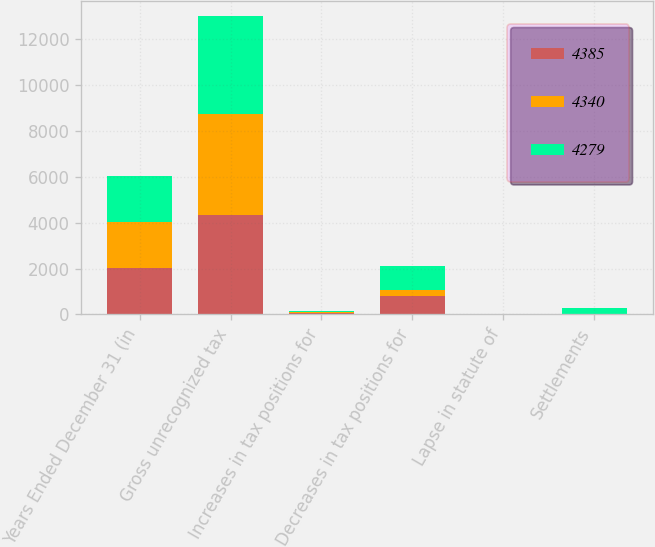Convert chart. <chart><loc_0><loc_0><loc_500><loc_500><stacked_bar_chart><ecel><fcel>Years Ended December 31 (in<fcel>Gross unrecognized tax<fcel>Increases in tax positions for<fcel>Decreases in tax positions for<fcel>Lapse in statute of<fcel>Settlements<nl><fcel>4385<fcel>2013<fcel>4340<fcel>43<fcel>796<fcel>20<fcel>2<nl><fcel>4340<fcel>2012<fcel>4385<fcel>47<fcel>264<fcel>8<fcel>5<nl><fcel>4279<fcel>2011<fcel>4279<fcel>48<fcel>1046<fcel>7<fcel>259<nl></chart> 